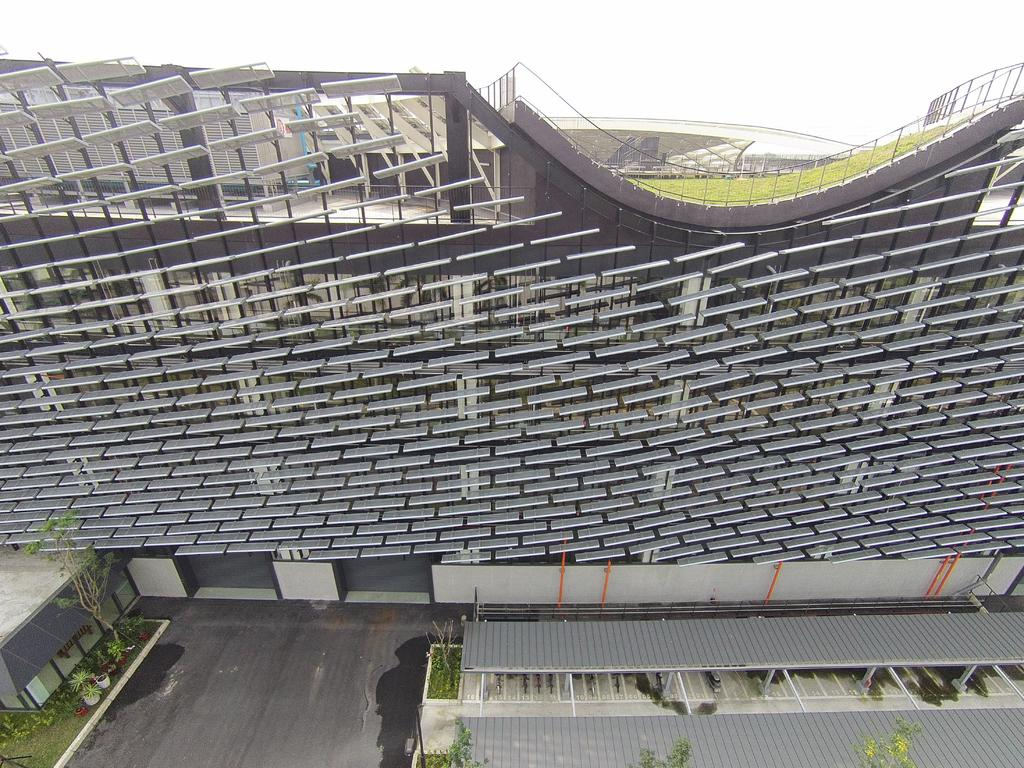What type of structure is in the image? There is an architecture building in the image. What can be seen at the bottom of the image? Trees, flower pots, grass, and sheds are present at the bottom of the image. What is visible in the background of the image? The sky is visible in the background of the image. Can you tell me how many people are walking and skating in the image? There are no people walking or skating in the image. What time of day is it in the image, considering the presence of the afternoon sun? The image does not provide any information about the time of day, and there is no mention of the sun in the facts provided. 